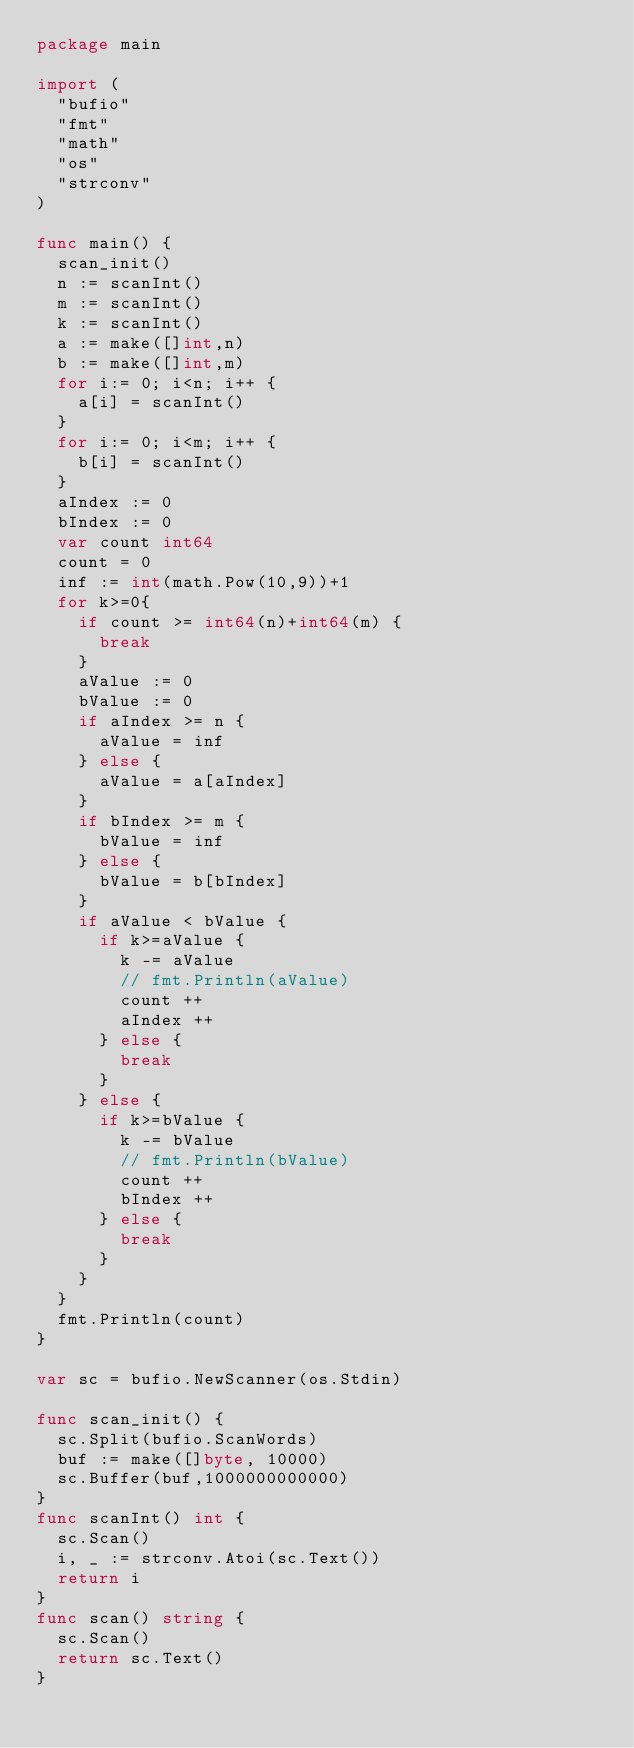<code> <loc_0><loc_0><loc_500><loc_500><_Go_>package main

import (
	"bufio"
	"fmt"
	"math"
	"os"
	"strconv"
)

func main() {
	scan_init()
	n := scanInt()
	m := scanInt()
	k := scanInt()
	a := make([]int,n)
	b := make([]int,m)
	for i:= 0; i<n; i++ {
		a[i] = scanInt()
	}
	for i:= 0; i<m; i++ {
		b[i] = scanInt()
	}
	aIndex := 0
	bIndex := 0
	var count int64
	count = 0
	inf := int(math.Pow(10,9))+1
	for k>=0{
		if count >= int64(n)+int64(m) {
			break
		}
		aValue := 0
		bValue := 0
		if aIndex >= n {
			aValue = inf
		} else {
			aValue = a[aIndex]
		}
		if bIndex >= m {
			bValue = inf
		} else {
			bValue = b[bIndex]
		}
		if aValue < bValue {
			if k>=aValue {
				k -= aValue
				// fmt.Println(aValue)
				count ++
				aIndex ++
			} else {
				break
			}
		} else {
			if k>=bValue {
				k -= bValue
				// fmt.Println(bValue)
				count ++
				bIndex ++
			} else {
				break
			}
		}
	}
	fmt.Println(count)
}

var sc = bufio.NewScanner(os.Stdin)

func scan_init() {
	sc.Split(bufio.ScanWords)
	buf := make([]byte, 10000)
	sc.Buffer(buf,1000000000000)
}
func scanInt() int {
	sc.Scan()
	i, _ := strconv.Atoi(sc.Text())
	return i
}
func scan() string {
	sc.Scan()
	return sc.Text()
}
</code> 